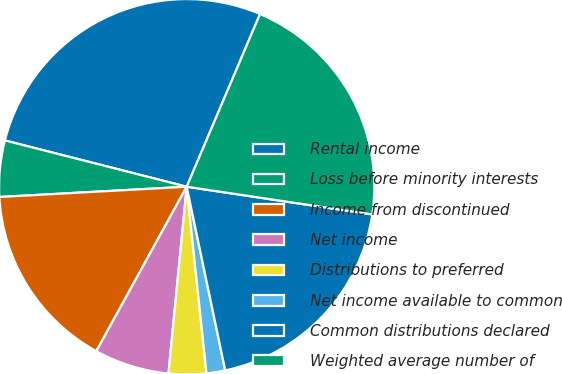Convert chart. <chart><loc_0><loc_0><loc_500><loc_500><pie_chart><fcel>Rental income<fcel>Loss before minority interests<fcel>Income from discontinued<fcel>Net income<fcel>Distributions to preferred<fcel>Net income available to common<fcel>Common distributions declared<fcel>Weighted average number of<nl><fcel>27.42%<fcel>4.84%<fcel>16.13%<fcel>6.45%<fcel>3.23%<fcel>1.61%<fcel>19.35%<fcel>20.97%<nl></chart> 